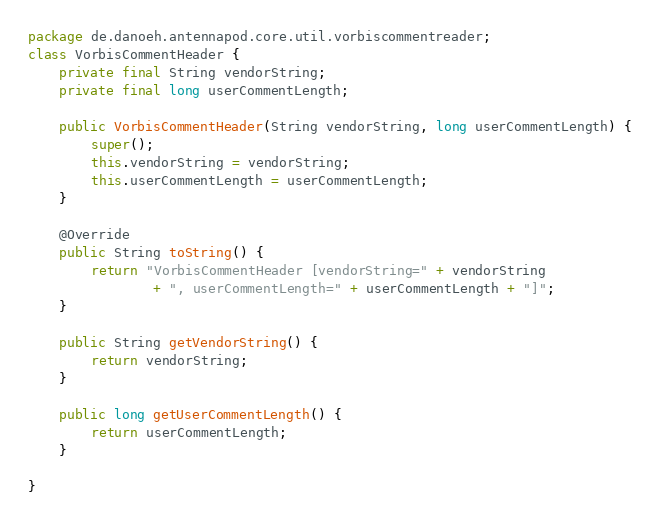<code> <loc_0><loc_0><loc_500><loc_500><_Java_>package de.danoeh.antennapod.core.util.vorbiscommentreader;
class VorbisCommentHeader {
	private final String vendorString;
	private final long userCommentLength;

	public VorbisCommentHeader(String vendorString, long userCommentLength) {
		super();
		this.vendorString = vendorString;
		this.userCommentLength = userCommentLength;
	}

	@Override
	public String toString() {
		return "VorbisCommentHeader [vendorString=" + vendorString
				+ ", userCommentLength=" + userCommentLength + "]";
	}

	public String getVendorString() {
		return vendorString;
	}

	public long getUserCommentLength() {
		return userCommentLength;
	}

}
</code> 